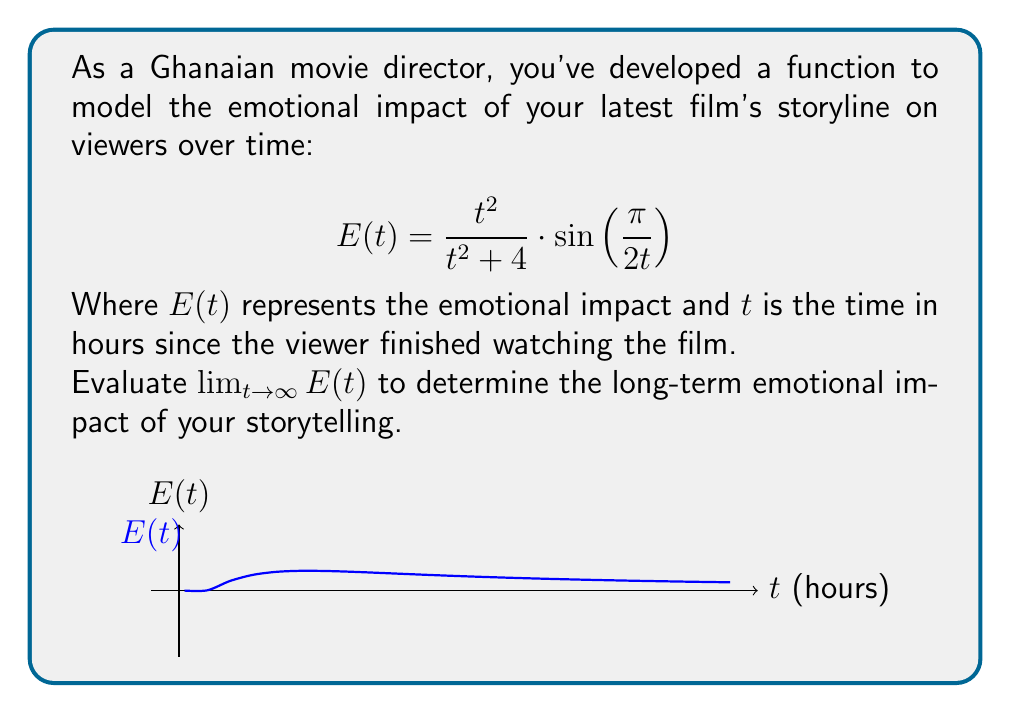Solve this math problem. To evaluate $\lim_{t \to \infty} E(t)$, let's break it down step-by-step:

1) First, let's consider the limit of each part of the function separately:

   a) $\lim_{t \to \infty} \frac{t^2}{t^2 + 4}$
   b) $\lim_{t \to \infty} \sin\left(\frac{\pi}{2t}\right)$

2) For part (a):
   $$\lim_{t \to \infty} \frac{t^2}{t^2 + 4} = \lim_{t \to \infty} \frac{1}{1 + \frac{4}{t^2}} = 1$$

3) For part (b):
   As $t \to \infty$, $\frac{\pi}{2t} \to 0$
   $$\lim_{t \to \infty} \sin\left(\frac{\pi}{2t}\right) = \sin(0) = 0$$

4) Now, we can combine these results:
   $$\lim_{t \to \infty} E(t) = \lim_{t \to \infty} \left(\frac{t^2}{t^2 + 4} \cdot \sin\left(\frac{\pi}{2t}\right)\right) = 1 \cdot 0 = 0$$

5) This result suggests that the emotional impact of the storyline approaches zero as time goes to infinity, indicating that the immediate strong emotions fade over time.
Answer: $0$ 